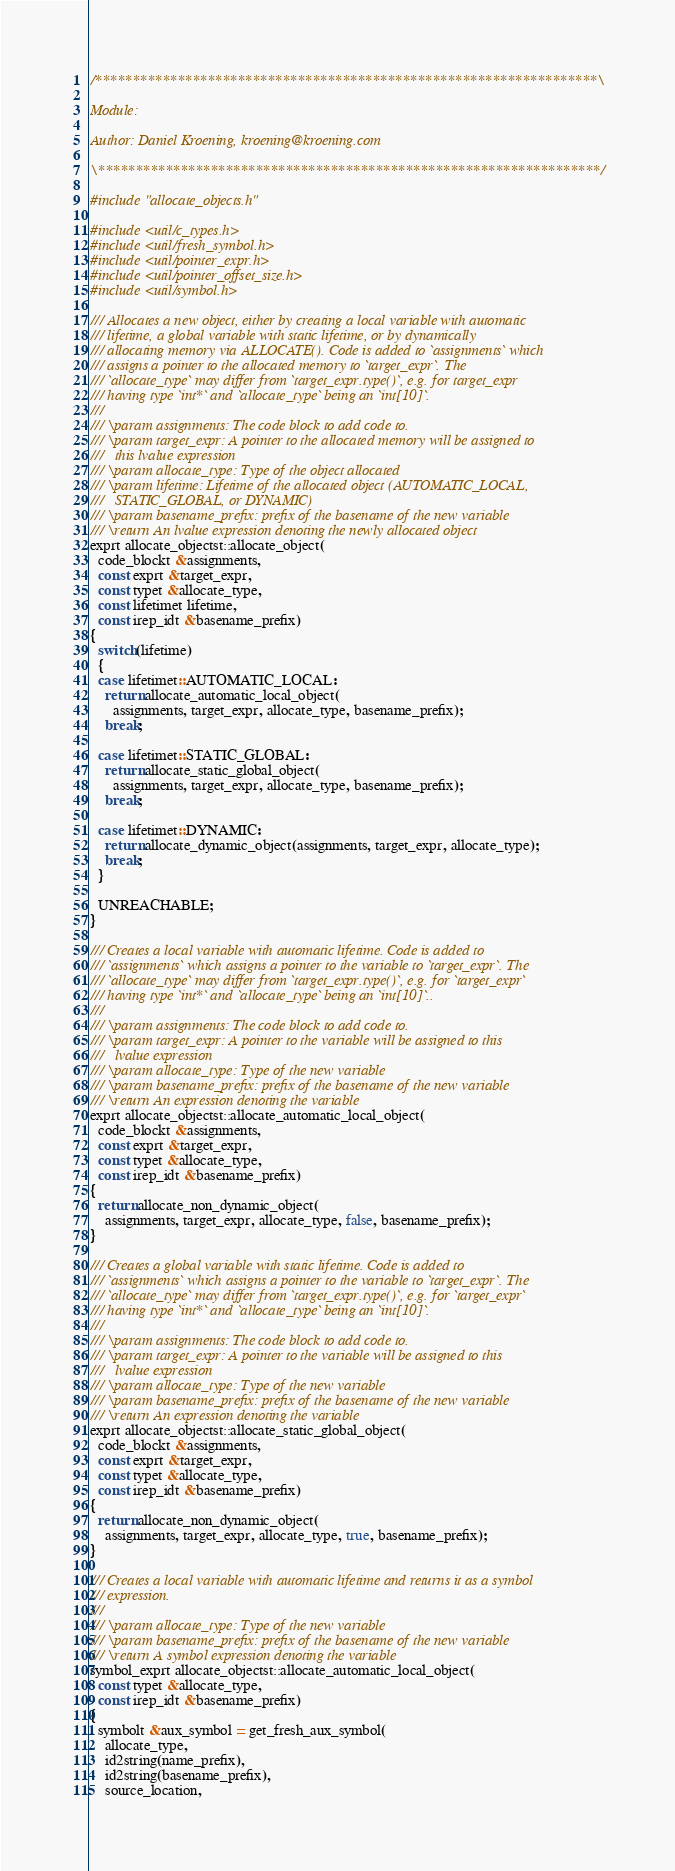Convert code to text. <code><loc_0><loc_0><loc_500><loc_500><_C++_>/*******************************************************************\

Module:

Author: Daniel Kroening, kroening@kroening.com

\*******************************************************************/

#include "allocate_objects.h"

#include <util/c_types.h>
#include <util/fresh_symbol.h>
#include <util/pointer_expr.h>
#include <util/pointer_offset_size.h>
#include <util/symbol.h>

/// Allocates a new object, either by creating a local variable with automatic
/// lifetime, a global variable with static lifetime, or by dynamically
/// allocating memory via ALLOCATE(). Code is added to `assignments` which
/// assigns a pointer to the allocated memory to `target_expr`. The
/// `allocate_type` may differ from `target_expr.type()`, e.g. for target_expr
/// having type `int*` and `allocate_type` being an `int[10]`.
///
/// \param assignments: The code block to add code to.
/// \param target_expr: A pointer to the allocated memory will be assigned to
///   this lvalue expression
/// \param allocate_type: Type of the object allocated
/// \param lifetime: Lifetime of the allocated object (AUTOMATIC_LOCAL,
///   STATIC_GLOBAL, or DYNAMIC)
/// \param basename_prefix: prefix of the basename of the new variable
/// \return An lvalue expression denoting the newly allocated object
exprt allocate_objectst::allocate_object(
  code_blockt &assignments,
  const exprt &target_expr,
  const typet &allocate_type,
  const lifetimet lifetime,
  const irep_idt &basename_prefix)
{
  switch(lifetime)
  {
  case lifetimet::AUTOMATIC_LOCAL:
    return allocate_automatic_local_object(
      assignments, target_expr, allocate_type, basename_prefix);
    break;

  case lifetimet::STATIC_GLOBAL:
    return allocate_static_global_object(
      assignments, target_expr, allocate_type, basename_prefix);
    break;

  case lifetimet::DYNAMIC:
    return allocate_dynamic_object(assignments, target_expr, allocate_type);
    break;
  }

  UNREACHABLE;
}

/// Creates a local variable with automatic lifetime. Code is added to
/// `assignments` which assigns a pointer to the variable to `target_expr`. The
/// `allocate_type` may differ from `target_expr.type()`, e.g. for `target_expr`
/// having type `int*` and `allocate_type` being an `int[10]`..
///
/// \param assignments: The code block to add code to.
/// \param target_expr: A pointer to the variable will be assigned to this
///   lvalue expression
/// \param allocate_type: Type of the new variable
/// \param basename_prefix: prefix of the basename of the new variable
/// \return An expression denoting the variable
exprt allocate_objectst::allocate_automatic_local_object(
  code_blockt &assignments,
  const exprt &target_expr,
  const typet &allocate_type,
  const irep_idt &basename_prefix)
{
  return allocate_non_dynamic_object(
    assignments, target_expr, allocate_type, false, basename_prefix);
}

/// Creates a global variable with static lifetime. Code is added to
/// `assignments` which assigns a pointer to the variable to `target_expr`. The
/// `allocate_type` may differ from `target_expr.type()`, e.g. for `target_expr`
/// having type `int*` and `allocate_type` being an `int[10]`.
///
/// \param assignments: The code block to add code to.
/// \param target_expr: A pointer to the variable will be assigned to this
///   lvalue expression
/// \param allocate_type: Type of the new variable
/// \param basename_prefix: prefix of the basename of the new variable
/// \return An expression denoting the variable
exprt allocate_objectst::allocate_static_global_object(
  code_blockt &assignments,
  const exprt &target_expr,
  const typet &allocate_type,
  const irep_idt &basename_prefix)
{
  return allocate_non_dynamic_object(
    assignments, target_expr, allocate_type, true, basename_prefix);
}

/// Creates a local variable with automatic lifetime and returns it as a symbol
/// expression.
///
/// \param allocate_type: Type of the new variable
/// \param basename_prefix: prefix of the basename of the new variable
/// \return A symbol expression denoting the variable
symbol_exprt allocate_objectst::allocate_automatic_local_object(
  const typet &allocate_type,
  const irep_idt &basename_prefix)
{
  symbolt &aux_symbol = get_fresh_aux_symbol(
    allocate_type,
    id2string(name_prefix),
    id2string(basename_prefix),
    source_location,</code> 